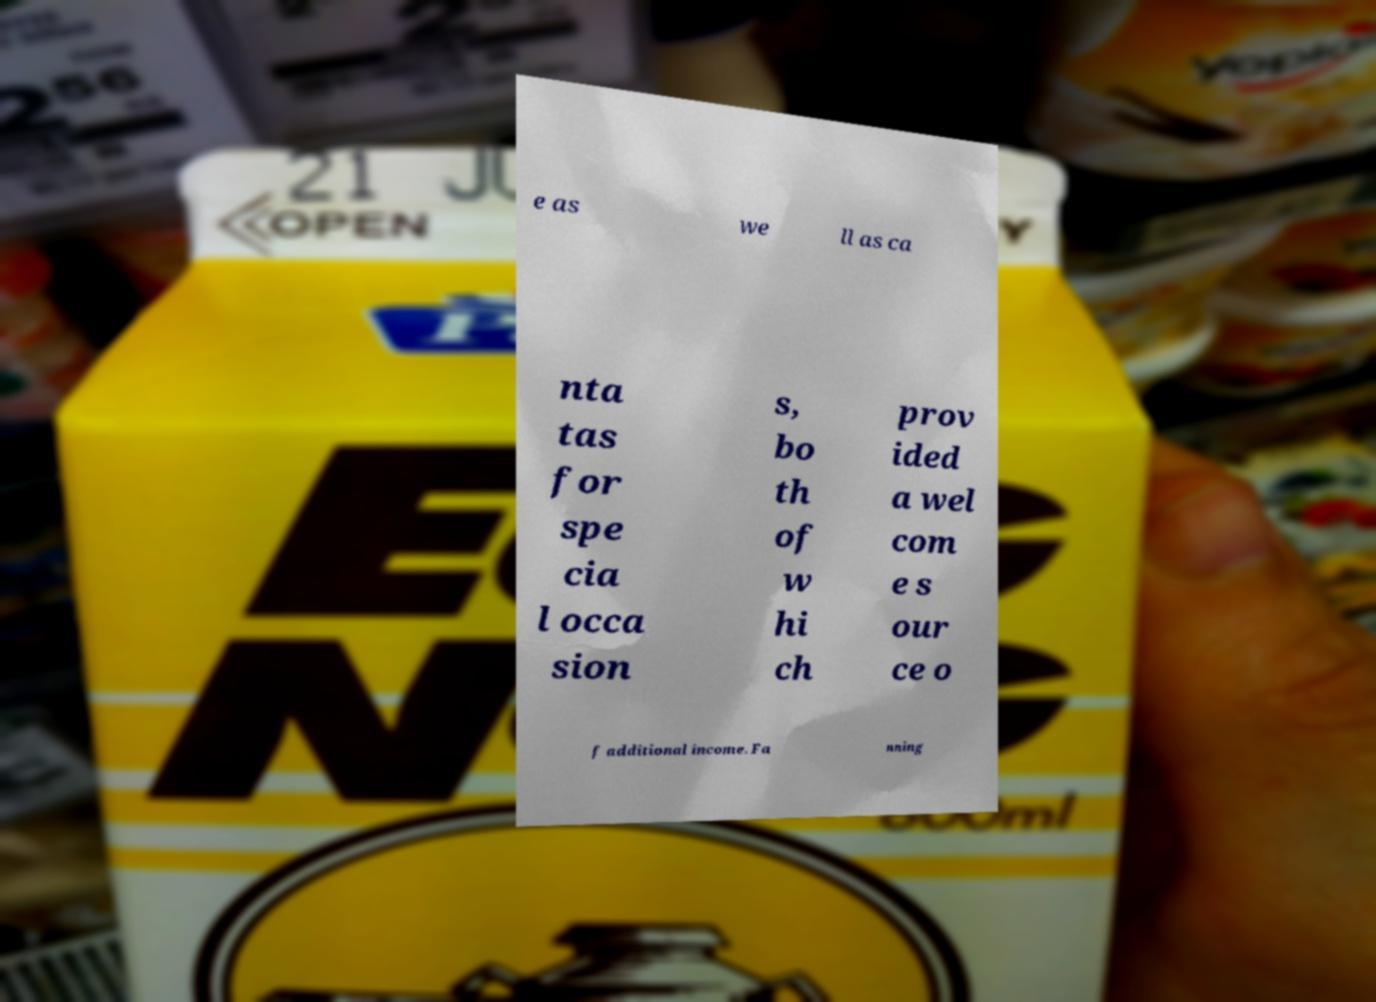What messages or text are displayed in this image? I need them in a readable, typed format. e as we ll as ca nta tas for spe cia l occa sion s, bo th of w hi ch prov ided a wel com e s our ce o f additional income. Fa nning 